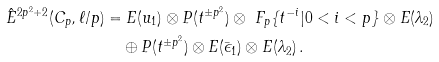<formula> <loc_0><loc_0><loc_500><loc_500>\hat { E } ^ { 2 p ^ { 2 } + 2 } ( C _ { p } , \ell / p ) & = E ( u _ { 1 } ) \otimes P ( t ^ { \pm p ^ { 2 } } ) \otimes \ F _ { p } \{ t ^ { - i } | 0 < i < p \} \otimes E ( \lambda _ { 2 } ) \\ & \quad \oplus P ( t ^ { \pm p ^ { 2 } } ) \otimes E ( \bar { \epsilon } _ { 1 } ) \otimes E ( \lambda _ { 2 } ) \, .</formula> 